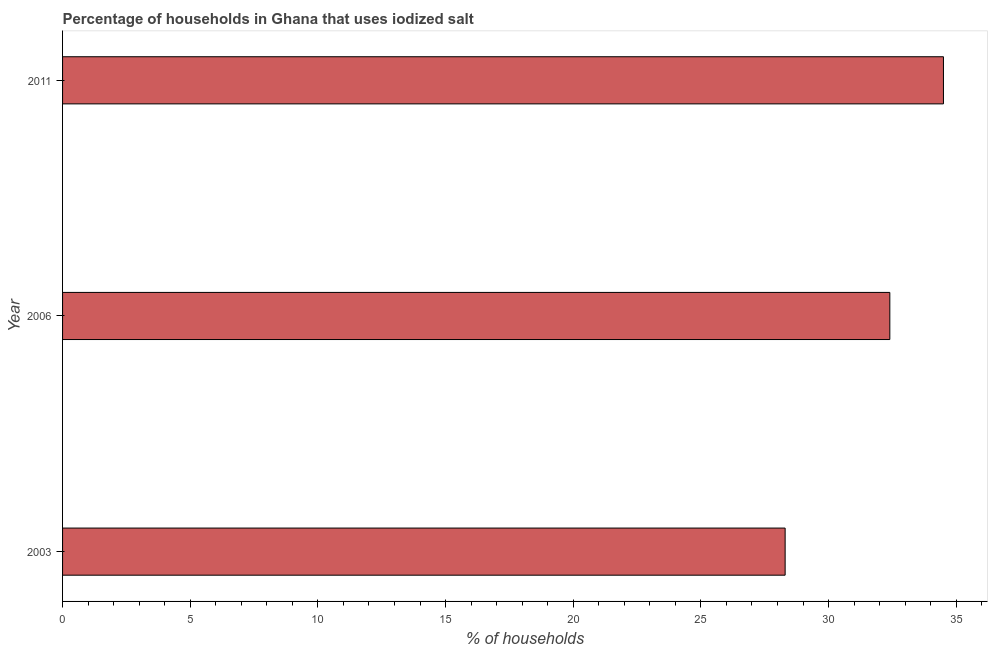Does the graph contain any zero values?
Give a very brief answer. No. What is the title of the graph?
Your answer should be compact. Percentage of households in Ghana that uses iodized salt. What is the label or title of the X-axis?
Give a very brief answer. % of households. What is the percentage of households where iodized salt is consumed in 2011?
Your answer should be compact. 34.5. Across all years, what is the maximum percentage of households where iodized salt is consumed?
Your answer should be very brief. 34.5. Across all years, what is the minimum percentage of households where iodized salt is consumed?
Offer a very short reply. 28.3. In which year was the percentage of households where iodized salt is consumed minimum?
Provide a succinct answer. 2003. What is the sum of the percentage of households where iodized salt is consumed?
Your answer should be compact. 95.2. What is the average percentage of households where iodized salt is consumed per year?
Keep it short and to the point. 31.73. What is the median percentage of households where iodized salt is consumed?
Your answer should be very brief. 32.4. What is the ratio of the percentage of households where iodized salt is consumed in 2003 to that in 2011?
Provide a short and direct response. 0.82. Is the percentage of households where iodized salt is consumed in 2006 less than that in 2011?
Provide a succinct answer. Yes. Is the difference between the percentage of households where iodized salt is consumed in 2006 and 2011 greater than the difference between any two years?
Your answer should be compact. No. What is the difference between the highest and the lowest percentage of households where iodized salt is consumed?
Provide a succinct answer. 6.2. In how many years, is the percentage of households where iodized salt is consumed greater than the average percentage of households where iodized salt is consumed taken over all years?
Give a very brief answer. 2. Are all the bars in the graph horizontal?
Ensure brevity in your answer.  Yes. How many years are there in the graph?
Ensure brevity in your answer.  3. What is the difference between two consecutive major ticks on the X-axis?
Make the answer very short. 5. Are the values on the major ticks of X-axis written in scientific E-notation?
Keep it short and to the point. No. What is the % of households of 2003?
Ensure brevity in your answer.  28.3. What is the % of households in 2006?
Your response must be concise. 32.4. What is the % of households in 2011?
Give a very brief answer. 34.5. What is the difference between the % of households in 2003 and 2006?
Provide a short and direct response. -4.1. What is the ratio of the % of households in 2003 to that in 2006?
Offer a terse response. 0.87. What is the ratio of the % of households in 2003 to that in 2011?
Provide a succinct answer. 0.82. What is the ratio of the % of households in 2006 to that in 2011?
Provide a succinct answer. 0.94. 